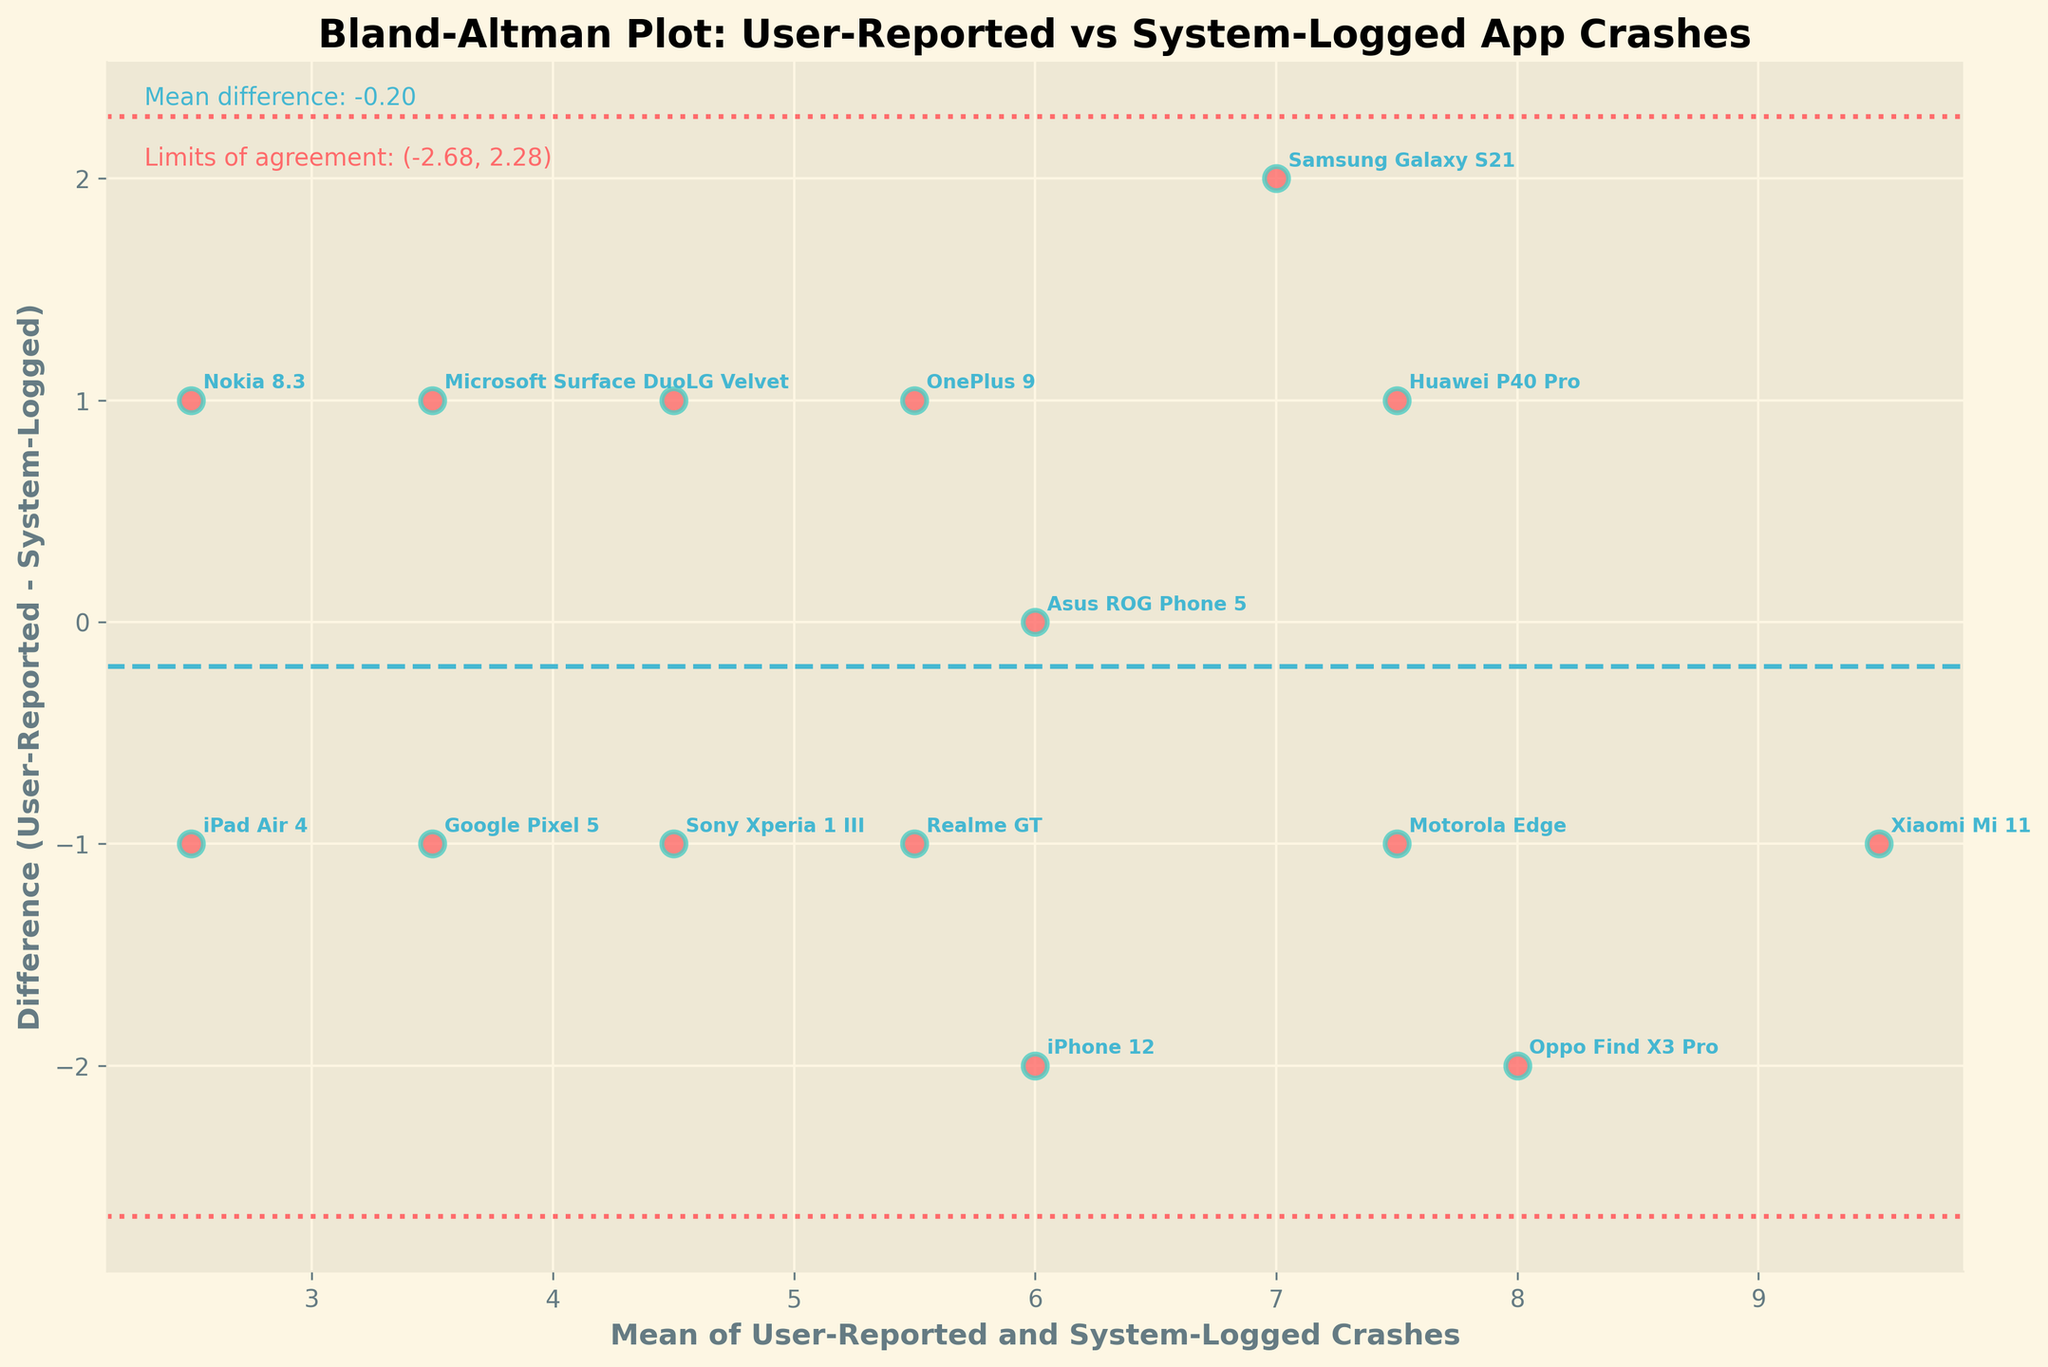What's the title of the plot? The title of the plot is displayed at the top of the figure. By reading the text, we can identify what the plot is about.
Answer: Bland-Altman Plot: User-Reported vs System-Logged App Crashes How many device models are represented in the plot? We can count the number of individual data points (scatter points) on the plot to determine the number of device models represented.
Answer: 15 What does the x-axis represent? The x-axis label is provided directly in the figure, and it indicates what the horizontal axis measures.
Answer: Mean of User-Reported and System-Logged Crashes What does the y-axis represent? The y-axis label is provided directly in the figure, and it indicates what the vertical axis measures.
Answer: Difference (User-Reported - System-Logged) Which device model has the largest positive difference between user-reported and system-logged crashes? By looking at the highest point on the y-axis, we can identify which device model corresponds to the largest positive difference.
Answer: Oppo Find X3 Pro Which device model has the smallest mean of user-reported and system-logged crashes? By examining the leftmost scatter point on the x-axis, we can determine which device model has the smallest mean.
Answer: iPad Air 4 What's the overall mean difference between user-reported and system-logged crashes? There's a text annotation near the top of the figure that explicitly states the overall mean difference.
Answer: 0.27 What are the limits of agreement for the differences between user-reported and system-logged crashes? The limits of agreement are provided as text annotations on the plot. These values give the range within which most differences fall.
Answer: (-1.60, 2.13) Which device models have a system-logged crash frequency equal to the user-reported crash frequency? Points that lie exactly on the zero horizontal line represent device models where the user-reported and system-logged crashes are the same.
Answer: Asus ROG Phone 5 Is there any device model where the user-reported crashes are consistently higher than the system-logged crashes? By examining scatter points that are consistently above the zero horizontal line, we can identify any such device models.
Answer: Oppo Find X3 Pro 